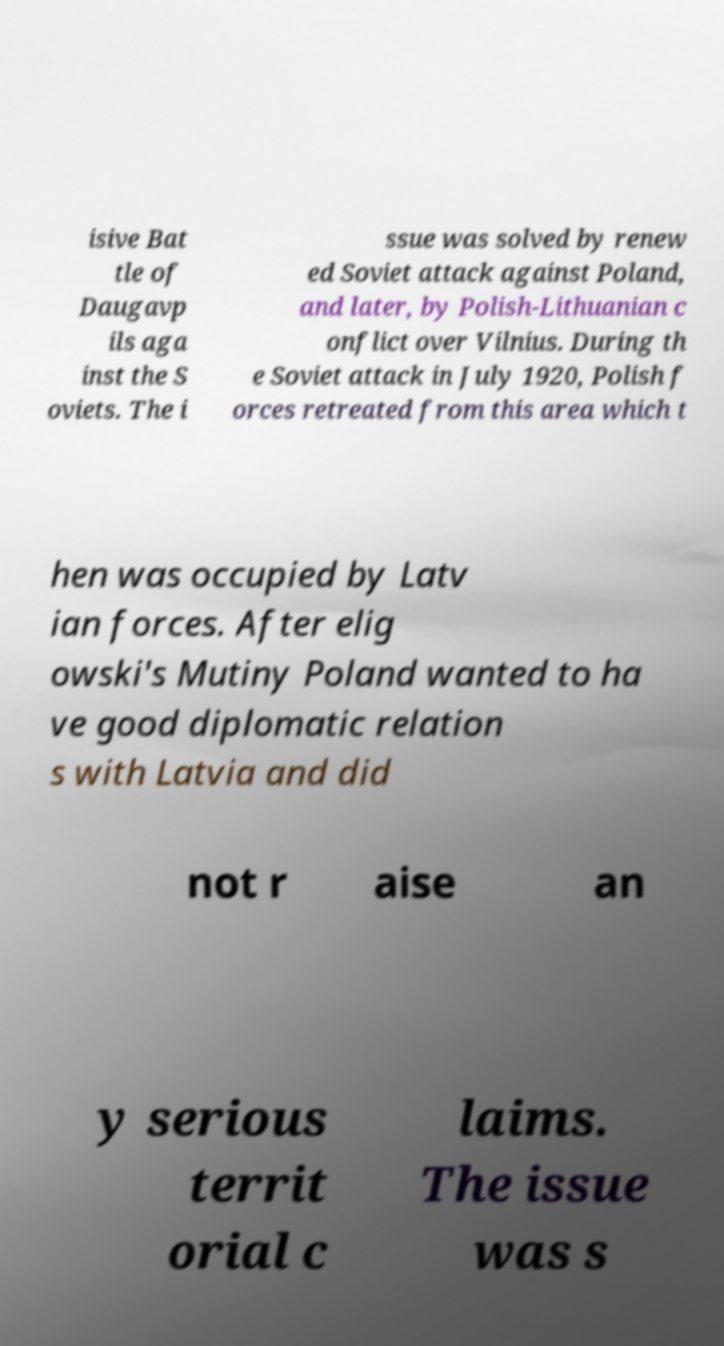Could you assist in decoding the text presented in this image and type it out clearly? isive Bat tle of Daugavp ils aga inst the S oviets. The i ssue was solved by renew ed Soviet attack against Poland, and later, by Polish-Lithuanian c onflict over Vilnius. During th e Soviet attack in July 1920, Polish f orces retreated from this area which t hen was occupied by Latv ian forces. After elig owski's Mutiny Poland wanted to ha ve good diplomatic relation s with Latvia and did not r aise an y serious territ orial c laims. The issue was s 